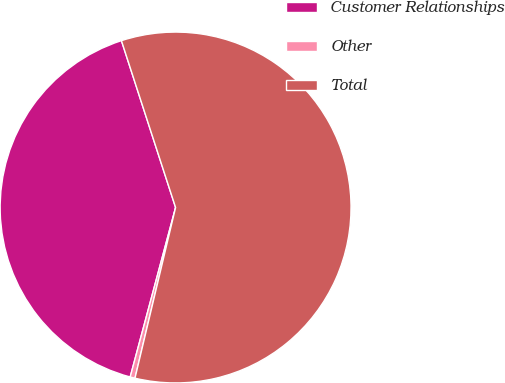Convert chart. <chart><loc_0><loc_0><loc_500><loc_500><pie_chart><fcel>Customer Relationships<fcel>Other<fcel>Total<nl><fcel>40.84%<fcel>0.45%<fcel>58.72%<nl></chart> 